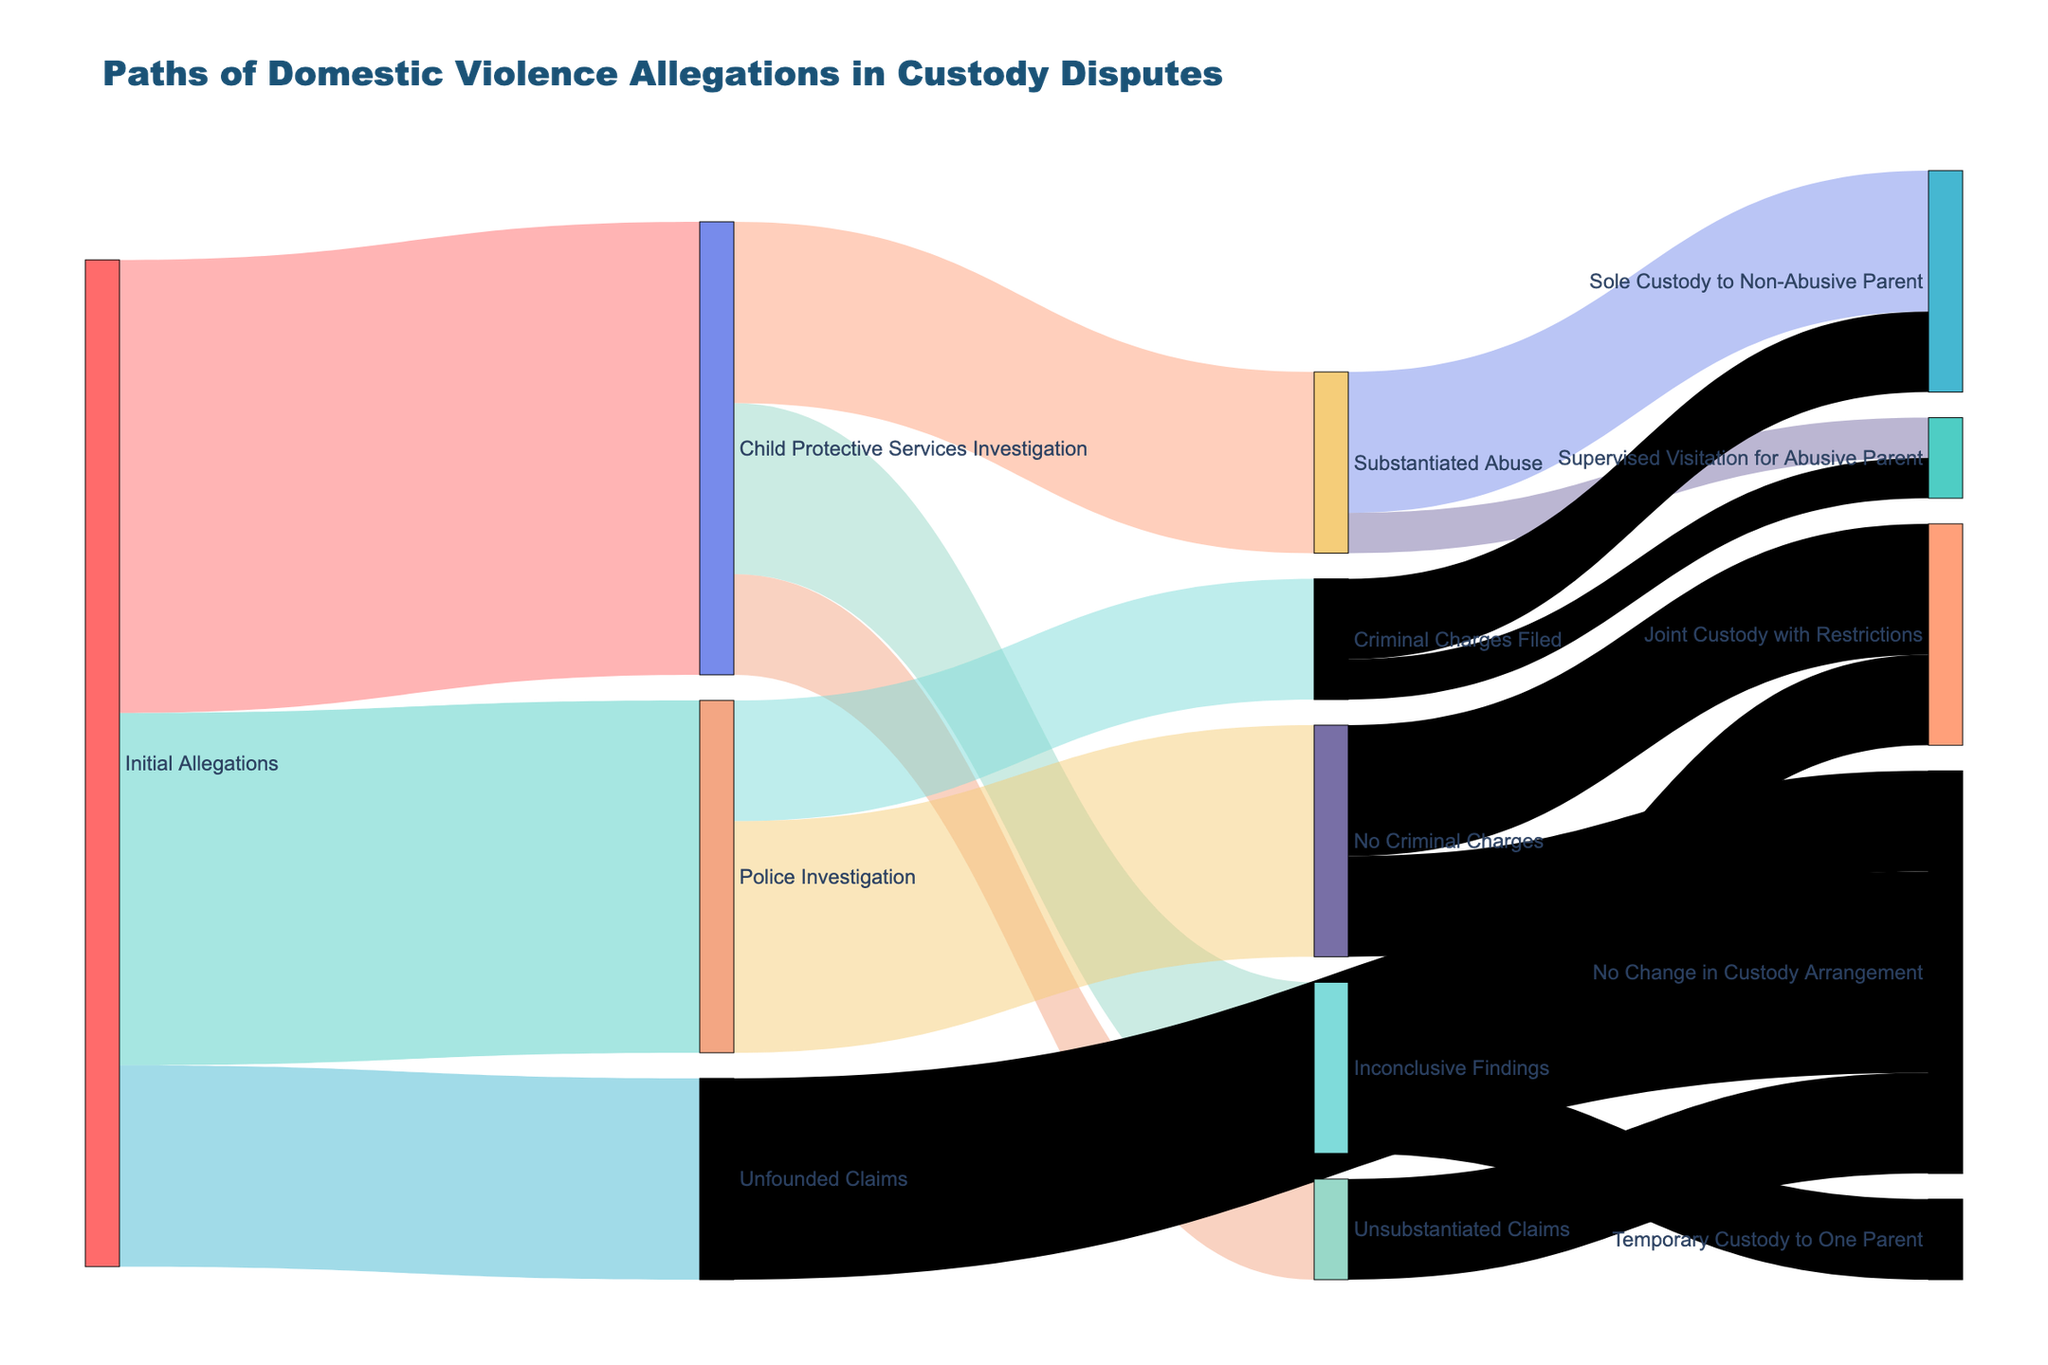What is the title of the figure? The title is stated at the top of the figure, which helps identify the main topic being visualized.
Answer: Paths of Domestic Violence Allegations in Custody Disputes How many initial allegations lead to Child Protective Services Investigation? Start from the "Initial Allegations" node and follow the path to the "Child Protective Services Investigation" node.
Answer: 450 Which outcome has the highest number of cases after Child Protective Services Investigation? Look at the branches coming out from the "Child Protective Services Investigation" node and compare their values.
Answer: Substantiated Abuse (180) How many paths result in no change in custody arrangement? Sum the values of branches ending in "No Change in Custody Arrangement" from "**Unsubstantiated Claims**, **No Criminal Charges**, and **Unfounded Claims**" nodes.
Answer: 400 What is the total number of cases where abuse was substantiated or criminal charges were filed? Sum the values for "**Substantiated Abuse**" and "**Criminal Charges Filed**" from their respective investigation nodes.
Answer: 300 (180 + 120) Which path leads to the fewest changes in custody arrangements? Compare the values of the branches ending in "**No Change in Custody Arrangement**" with other custody-related outcomes.
Answer: Unfounded Claims (200) How does the number of cases with inconclusive findings compare to those leading to Criminal Charges Filed? Compare the value from "**Child Protective Services Investigation**" to "**Inconclusive Findings**" (170) with "**Police Investigation**" to "**Criminal Charges Filed**" (120).
Answer: Inconclusive Findings have more cases (170 > 120) How many cases result in supervised visitation for abusive parents? Combine the values from paths ending in "**Supervised Visitation for Abusive Parent**" stemming from "**Substantiated Abuse**" and "**Criminal Charges Filed**".
Answer: 80 (40 + 40) What's the total number of cases that resulted in any change in custody arrangements? Sum all the values for the paths leading to different custody outcomes, excluding paths to "**No Change in Custody Arrangement**".
Answer: 550 (140+40+90+80+80+40+130) 